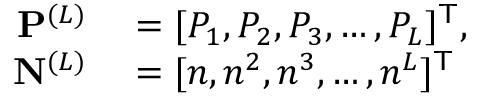<formula> <loc_0><loc_0><loc_500><loc_500>\begin{array} { r l } { \mathbf P ^ { ( L ) } } & = [ P _ { 1 } , P _ { 2 } , P _ { 3 } , \dots , P _ { L } ] ^ { \mathsf T } , } \\ { \mathbf N ^ { ( L ) } } & = [ n , n ^ { 2 } , n ^ { 3 } , \dots , n ^ { L } ] ^ { \mathsf T } } \end{array}</formula> 